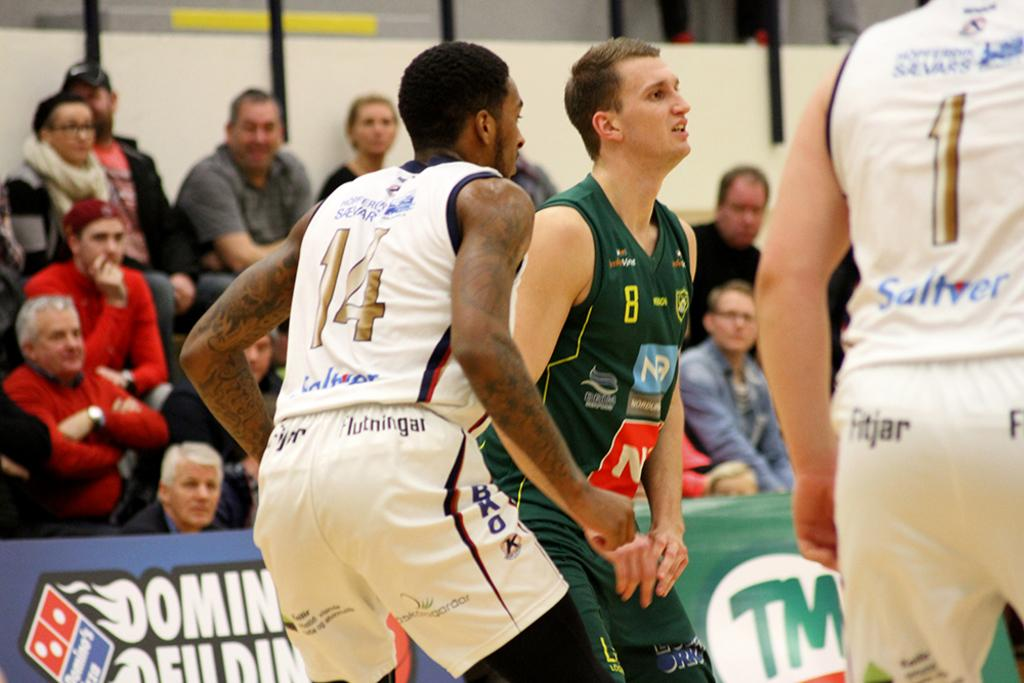What are the people in the image wearing? The people in the image are wearing sports dress. What are the people in the image doing? The people are standing. What can be seen on the wall in the image? There is a poster in the image. What are the audience members in the image doing? The audience members are sitting. What are the audience members wearing in the image? The audience members are wearing clothes. What type of bread can be seen being used as a prop in the image? There is no bread present in the image. What curve can be seen in the image? There is no curve mentioned or visible in the image. 